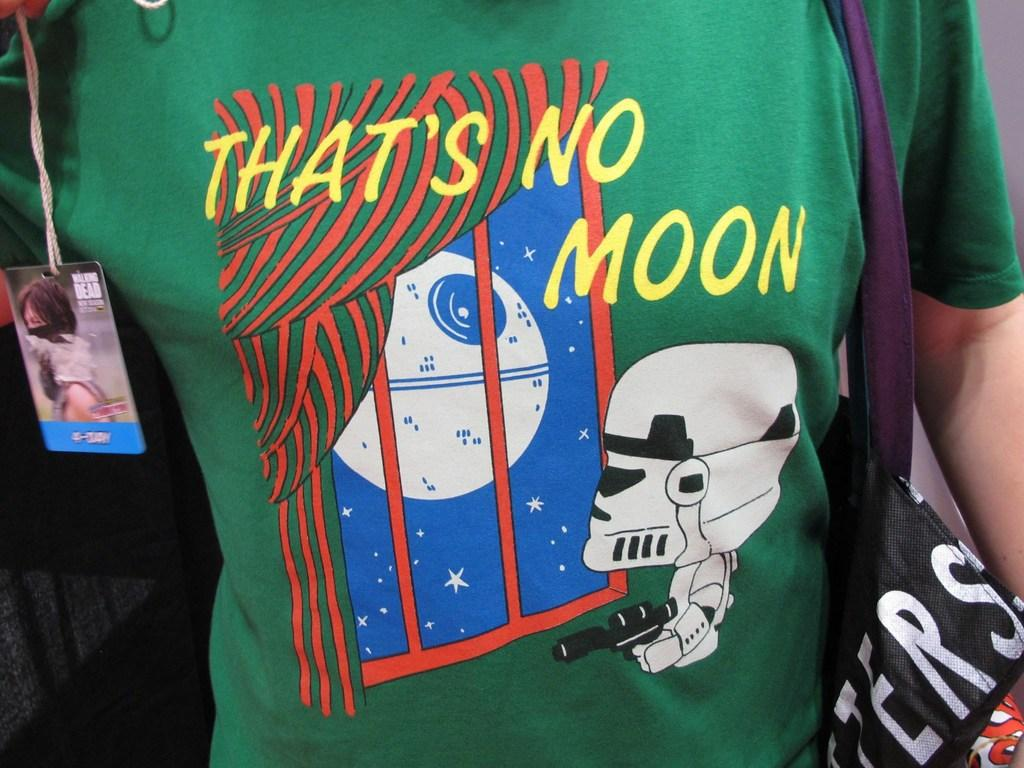<image>
Write a terse but informative summary of the picture. A shirt features a storm trooper and says That's No Moon. 